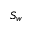Convert formula to latex. <formula><loc_0><loc_0><loc_500><loc_500>S _ { w }</formula> 